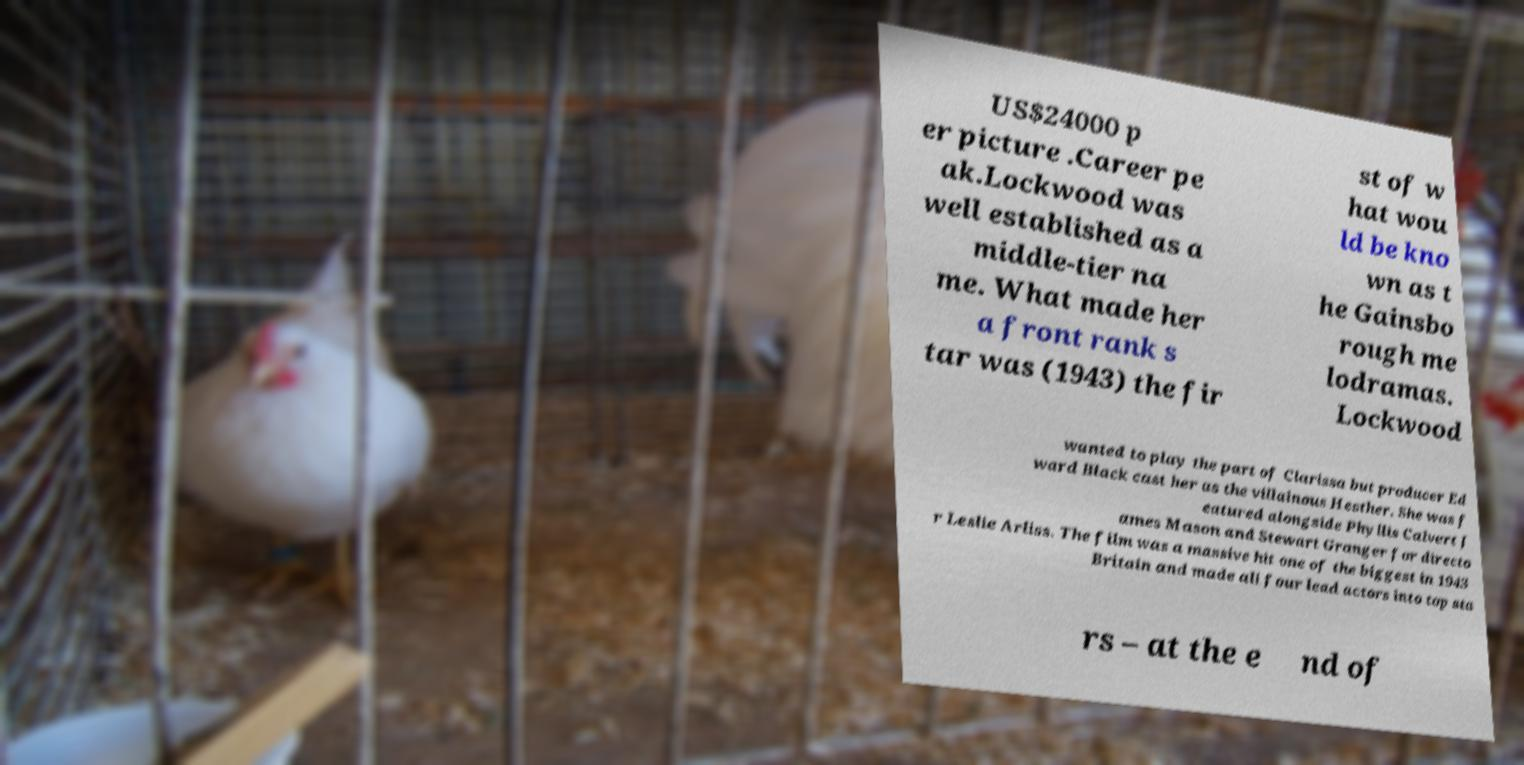Can you accurately transcribe the text from the provided image for me? US$24000 p er picture .Career pe ak.Lockwood was well established as a middle-tier na me. What made her a front rank s tar was (1943) the fir st of w hat wou ld be kno wn as t he Gainsbo rough me lodramas. Lockwood wanted to play the part of Clarissa but producer Ed ward Black cast her as the villainous Hesther. She was f eatured alongside Phyllis Calvert J ames Mason and Stewart Granger for directo r Leslie Arliss. The film was a massive hit one of the biggest in 1943 Britain and made all four lead actors into top sta rs – at the e nd of 